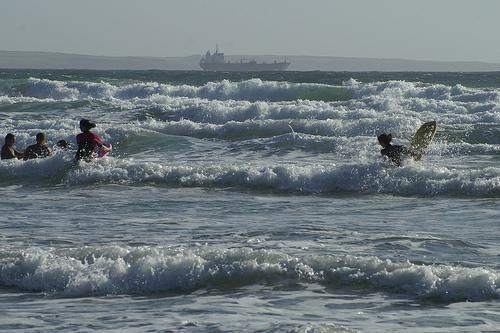How many people?
Give a very brief answer. 4. 